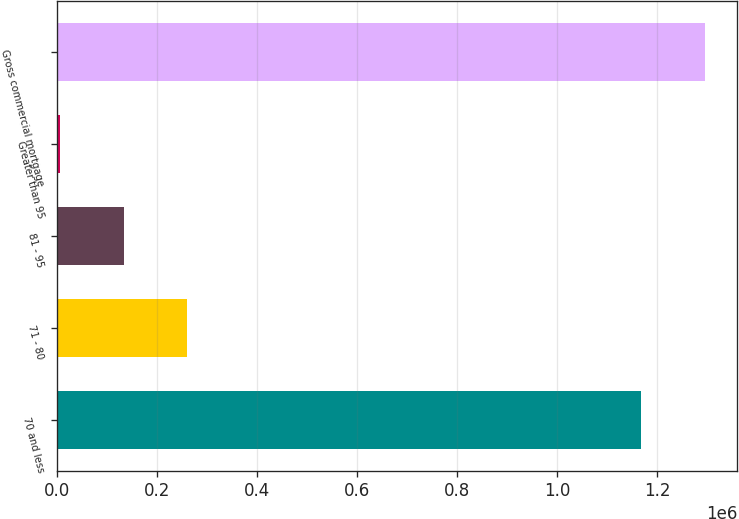<chart> <loc_0><loc_0><loc_500><loc_500><bar_chart><fcel>70 and less<fcel>71 - 80<fcel>81 - 95<fcel>Greater than 95<fcel>Gross commercial mortgage<nl><fcel>1.16845e+06<fcel>260428<fcel>133479<fcel>6531<fcel>1.2954e+06<nl></chart> 